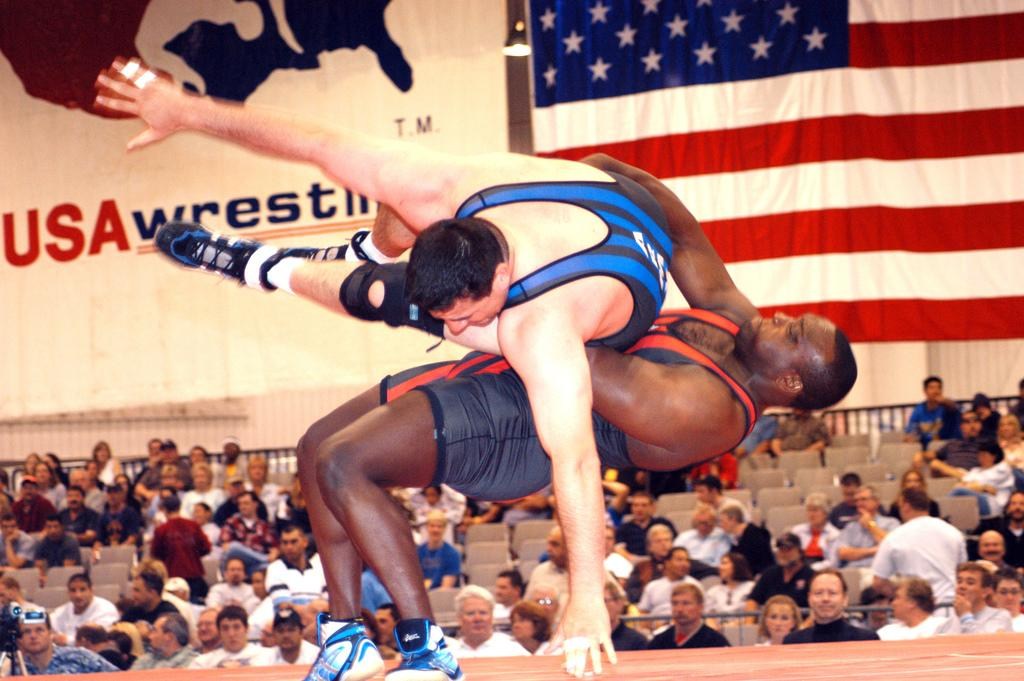What are the two persons in the image doing? The two persons in the image are playing wrestling. What can be seen in the background of the image? There are people sitting on chairs in the background of the image. What is the symbol or emblem present in the image? There is a flag in the image. What message or information is conveyed by the text in the image? There is a banner with text in the image, which may convey a message or information. What type of pear is being used as a prop in the wrestling match? There is no pear present in the image, and no props are mentioned in the wrestling match. 